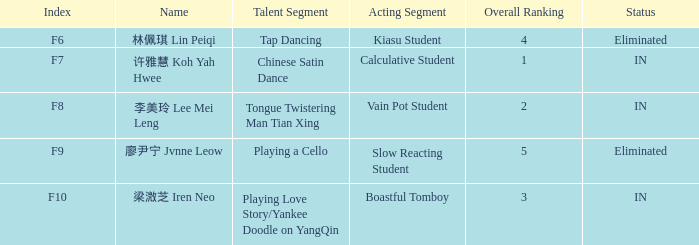For each incident with index f10, what is the aggregate of the general standings? 3.0. 